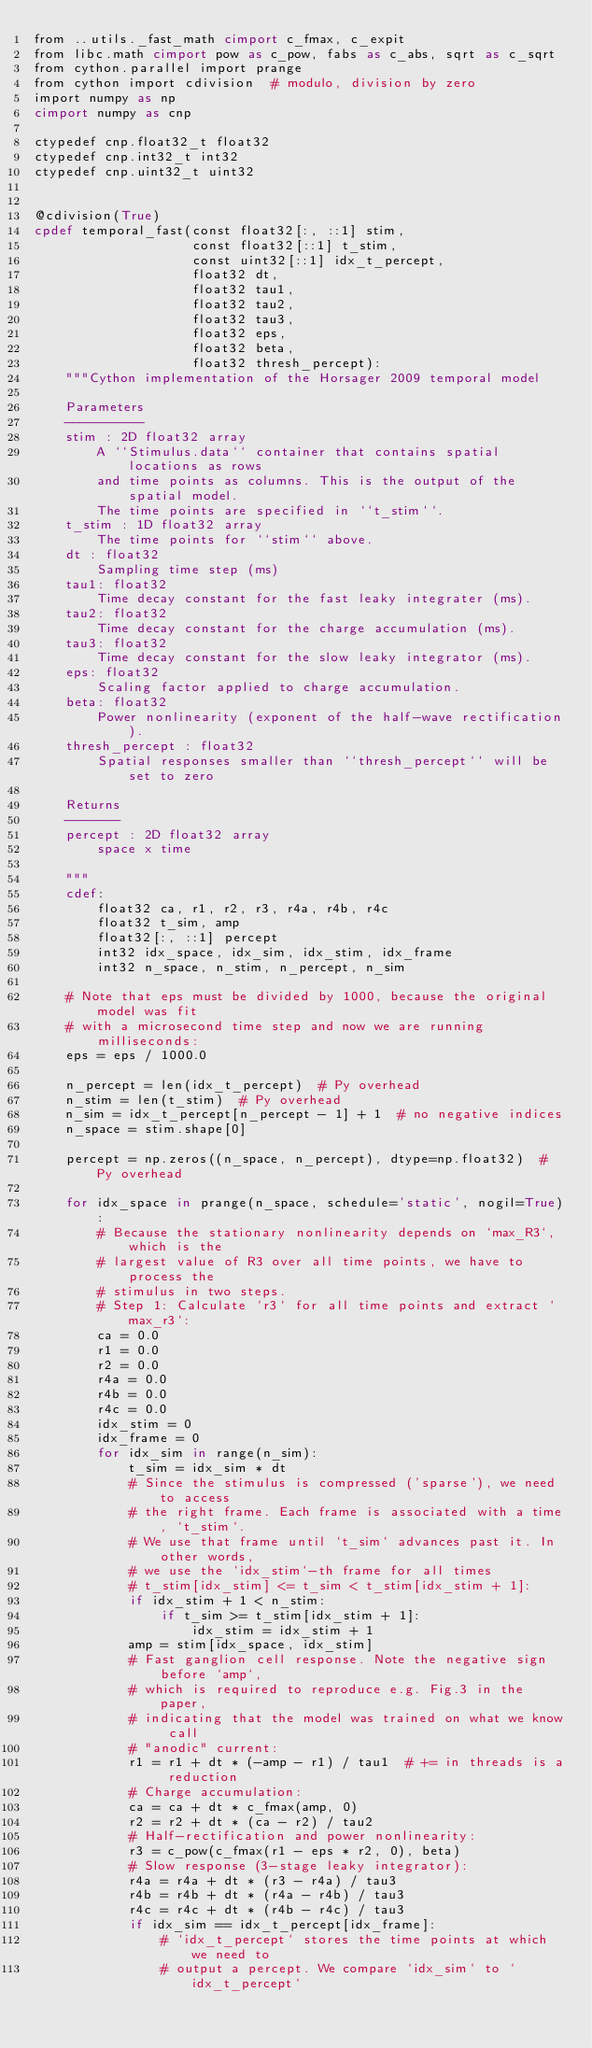<code> <loc_0><loc_0><loc_500><loc_500><_Cython_>from ..utils._fast_math cimport c_fmax, c_expit
from libc.math cimport pow as c_pow, fabs as c_abs, sqrt as c_sqrt
from cython.parallel import prange
from cython import cdivision  # modulo, division by zero
import numpy as np
cimport numpy as cnp

ctypedef cnp.float32_t float32
ctypedef cnp.int32_t int32
ctypedef cnp.uint32_t uint32


@cdivision(True)
cpdef temporal_fast(const float32[:, ::1] stim,
                    const float32[::1] t_stim,
                    const uint32[::1] idx_t_percept,
                    float32 dt,
                    float32 tau1,
                    float32 tau2,
                    float32 tau3,
                    float32 eps,
                    float32 beta,
                    float32 thresh_percept):
    """Cython implementation of the Horsager 2009 temporal model

    Parameters
    ----------
    stim : 2D float32 array
        A ``Stimulus.data`` container that contains spatial locations as rows
        and time points as columns. This is the output of the spatial model.
        The time points are specified in ``t_stim``.
    t_stim : 1D float32 array
        The time points for ``stim`` above.
    dt : float32
        Sampling time step (ms)
    tau1: float32
        Time decay constant for the fast leaky integrater (ms).
    tau2: float32
        Time decay constant for the charge accumulation (ms).
    tau3: float32
        Time decay constant for the slow leaky integrator (ms).
    eps: float32
        Scaling factor applied to charge accumulation.
    beta: float32
        Power nonlinearity (exponent of the half-wave rectification).
    thresh_percept : float32
        Spatial responses smaller than ``thresh_percept`` will be set to zero

    Returns
    -------
    percept : 2D float32 array
        space x time

    """
    cdef:
        float32 ca, r1, r2, r3, r4a, r4b, r4c
        float32 t_sim, amp
        float32[:, ::1] percept
        int32 idx_space, idx_sim, idx_stim, idx_frame
        int32 n_space, n_stim, n_percept, n_sim

    # Note that eps must be divided by 1000, because the original model was fit
    # with a microsecond time step and now we are running milliseconds:
    eps = eps / 1000.0

    n_percept = len(idx_t_percept)  # Py overhead
    n_stim = len(t_stim)  # Py overhead
    n_sim = idx_t_percept[n_percept - 1] + 1  # no negative indices
    n_space = stim.shape[0]

    percept = np.zeros((n_space, n_percept), dtype=np.float32)  # Py overhead

    for idx_space in prange(n_space, schedule='static', nogil=True):
        # Because the stationary nonlinearity depends on `max_R3`, which is the
        # largest value of R3 over all time points, we have to process the
        # stimulus in two steps.
        # Step 1: Calculate `r3` for all time points and extract `max_r3`:
        ca = 0.0
        r1 = 0.0
        r2 = 0.0
        r4a = 0.0
        r4b = 0.0
        r4c = 0.0
        idx_stim = 0
        idx_frame = 0
        for idx_sim in range(n_sim):
            t_sim = idx_sim * dt
            # Since the stimulus is compressed ('sparse'), we need to access
            # the right frame. Each frame is associated with a time, `t_stim`.
            # We use that frame until `t_sim` advances past it. In other words,
            # we use the `idx_stim`-th frame for all times
            # t_stim[idx_stim] <= t_sim < t_stim[idx_stim + 1]:
            if idx_stim + 1 < n_stim:
                if t_sim >= t_stim[idx_stim + 1]:
                    idx_stim = idx_stim + 1
            amp = stim[idx_space, idx_stim]
            # Fast ganglion cell response. Note the negative sign before `amp`,
            # which is required to reproduce e.g. Fig.3 in the paper,
            # indicating that the model was trained on what we know call
            # "anodic" current:
            r1 = r1 + dt * (-amp - r1) / tau1  # += in threads is a reduction
            # Charge accumulation:
            ca = ca + dt * c_fmax(amp, 0)
            r2 = r2 + dt * (ca - r2) / tau2
            # Half-rectification and power nonlinearity:
            r3 = c_pow(c_fmax(r1 - eps * r2, 0), beta)
            # Slow response (3-stage leaky integrator):
            r4a = r4a + dt * (r3 - r4a) / tau3
            r4b = r4b + dt * (r4a - r4b) / tau3
            r4c = r4c + dt * (r4b - r4c) / tau3
            if idx_sim == idx_t_percept[idx_frame]:
                # `idx_t_percept` stores the time points at which we need to
                # output a percept. We compare `idx_sim` to `idx_t_percept`</code> 